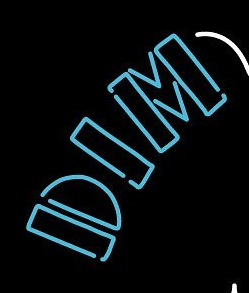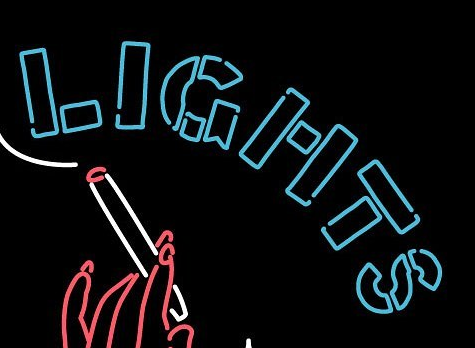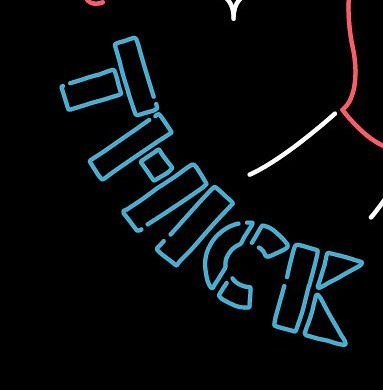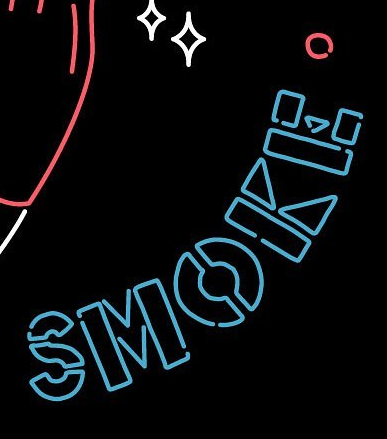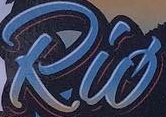Transcribe the words shown in these images in order, separated by a semicolon. DIM; LIGHTS; THICK; SMOKE; Rió 